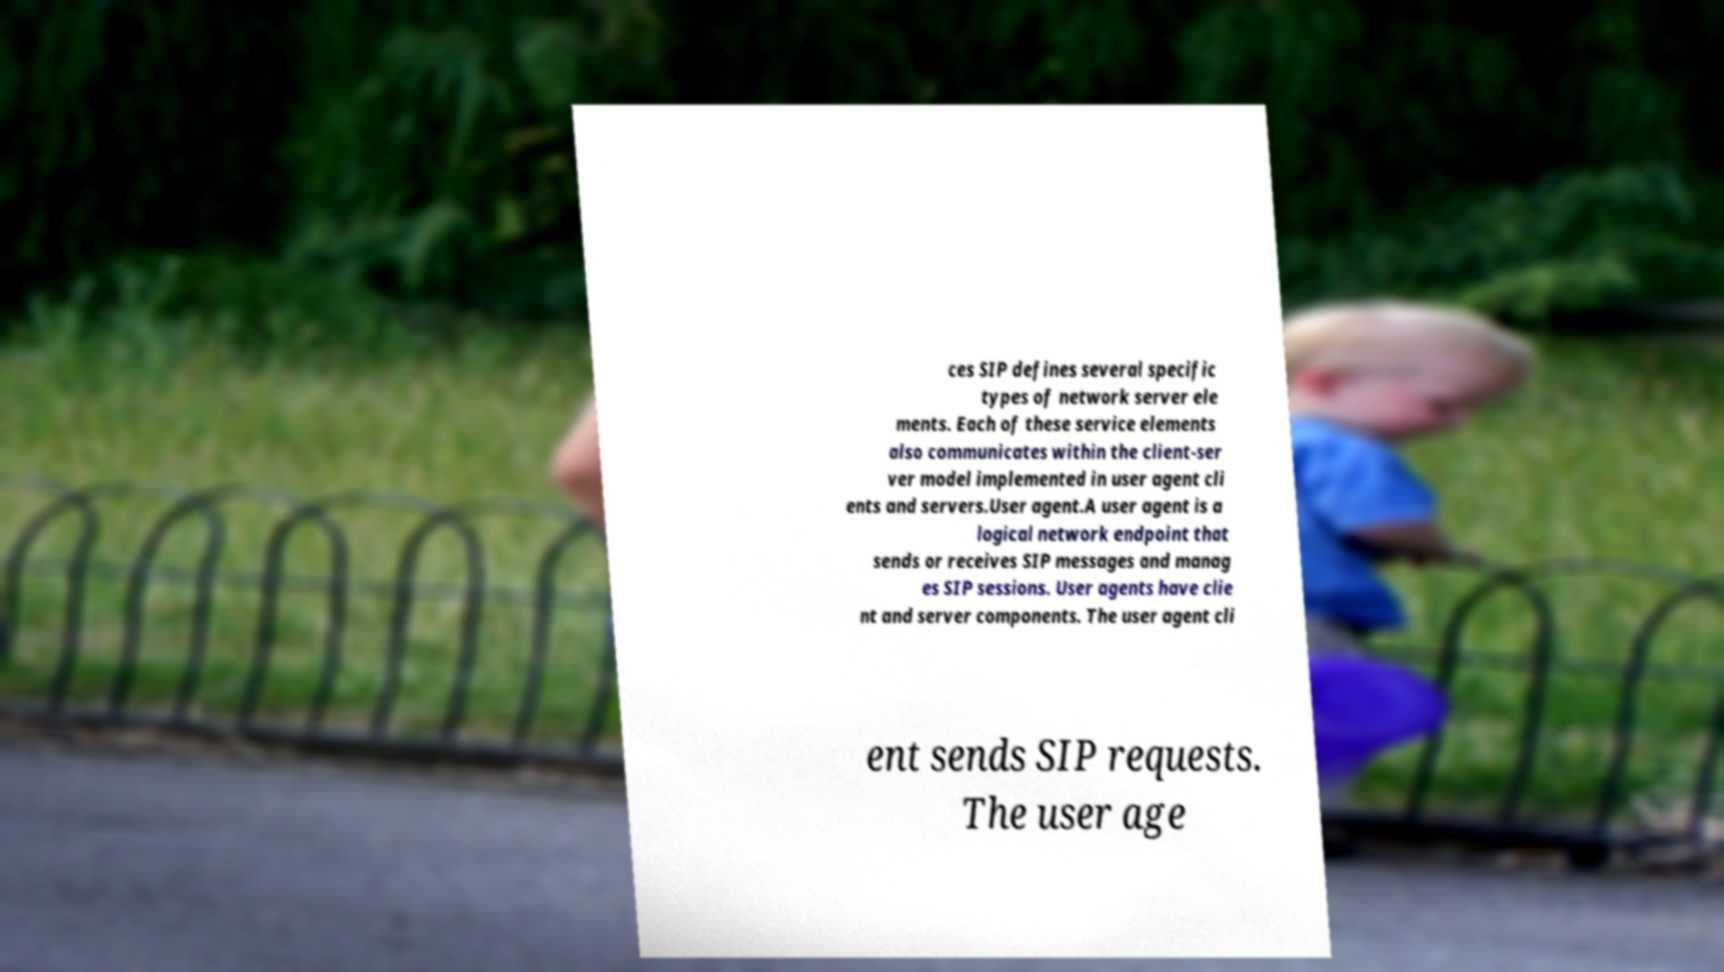For documentation purposes, I need the text within this image transcribed. Could you provide that? ces SIP defines several specific types of network server ele ments. Each of these service elements also communicates within the client-ser ver model implemented in user agent cli ents and servers.User agent.A user agent is a logical network endpoint that sends or receives SIP messages and manag es SIP sessions. User agents have clie nt and server components. The user agent cli ent sends SIP requests. The user age 